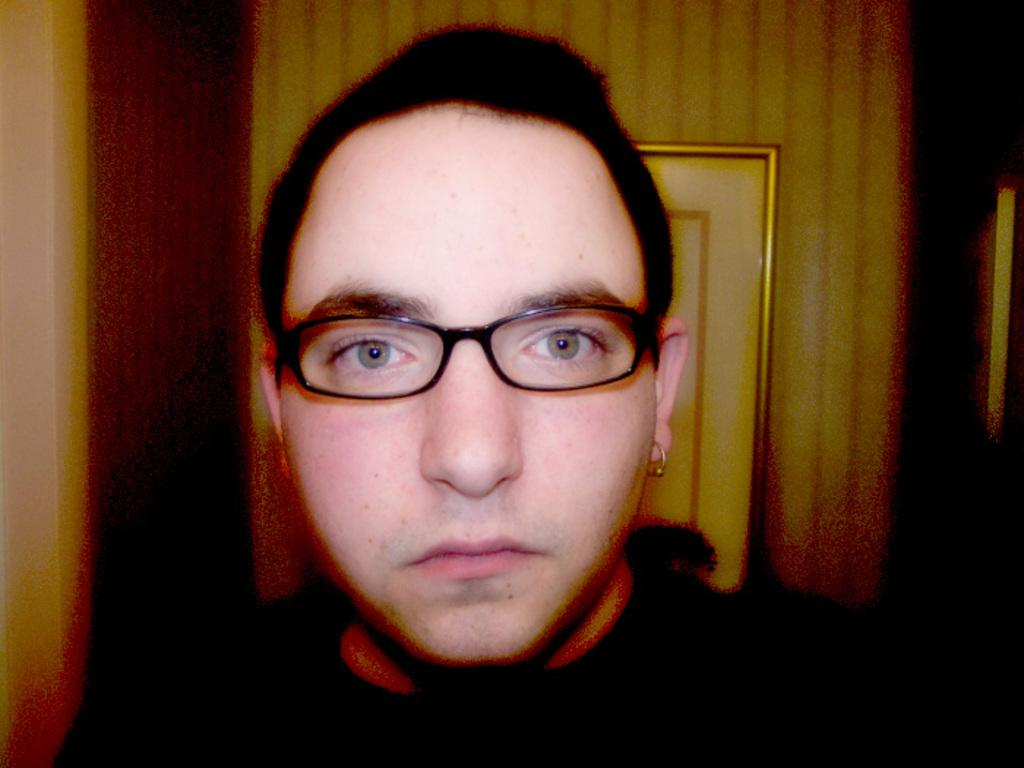Who or what is present in the image? There is a person in the image. Can you describe the person's appearance? The person is wearing spectacles and an earring. What else can be seen in the image? There is a photo frame in the image. How many jellyfish are swimming in the photo frame in the image? There are no jellyfish present in the image, and the photo frame does not depict any aquatic creatures. 